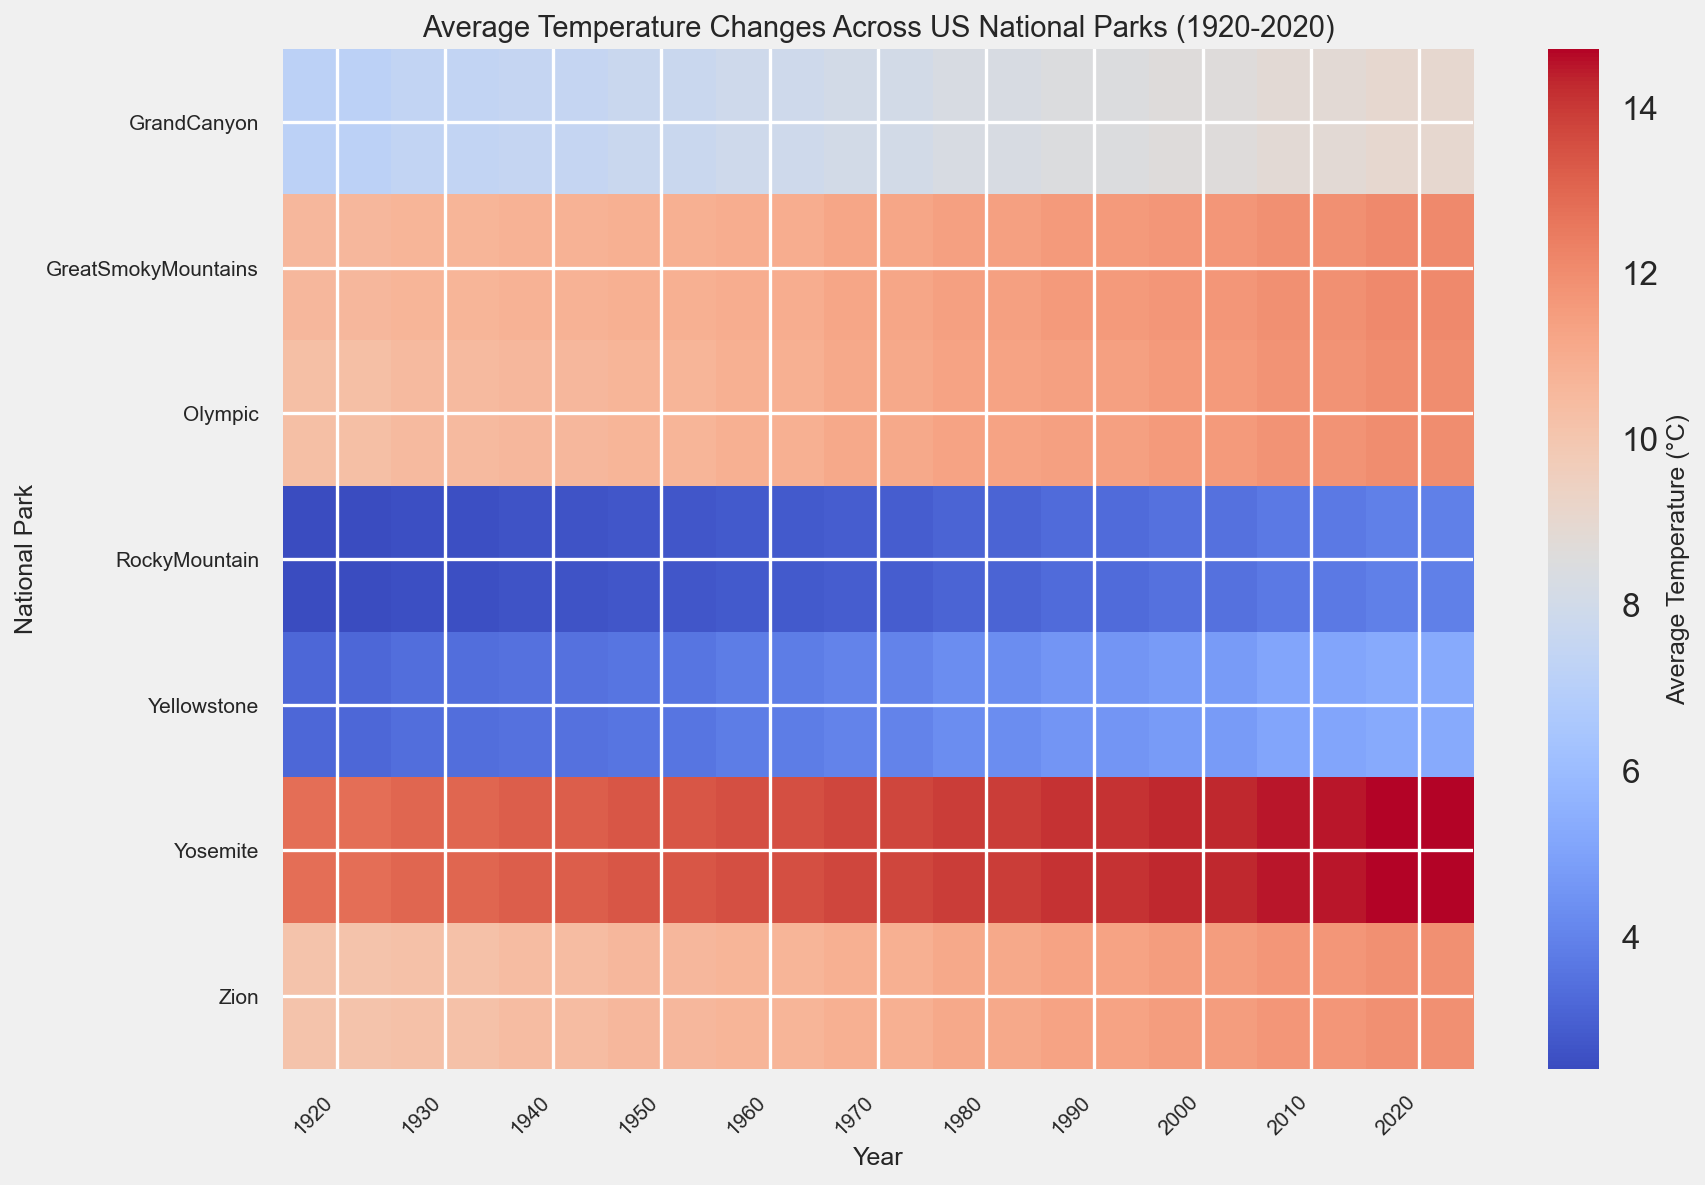What's the overall trend in average temperature for Yellowstone over the last century? By observing the color gradient from 1920 to 2020 for Yellowstone, we can see that the colors shift from cooler (bluer) to warmer (redder) over time. This indicates an increasing trend in average temperature.
Answer: Increase Which park has experienced the highest increase in average temperature from 1920 to 2020? To determine this, compare the gradient change in colors over time for each park. RockyMountain shows the smallest color change from a cooler to warmer shade, meaning it has the least increase, whereas Yellowstone shows a significant change from blue to red, indicating the highest increase.
Answer: Yellowstone In which decade did Great Smoky Mountains see the most significant temperature rise? Look at the color transition in the Great Smoky Mountains row; the most noticeable change occurs between 1980 and 1990, shifting from a cooler to a warmer color.
Answer: 1980-1990 By how many degrees has the average temperature in Zion changed from 1920 to 2020? Reference the pivot data or color transitions; in 1920, the temperature was 10.1°C and in 2020 it is 11.9°C. The difference is 11.9 - 10.1 = 1.8°C.
Answer: 1.8°C Compare the average temperature change between Olympic and Yosemite from 1920 to 2020. Which one had a larger change? For Olympic, the change is from 10.3°C to 12.0°C, which is 1.7°C. For Yosemite, the change is from 12.8°C to 14.7°C, which is 1.9°C. Yosemite has a larger change.
Answer: Yosemite Which park had the coolest average temperature in 1920? Look at the colors in the 1920 column; RockyMountain is the coolest as indicated by the darkest blue shade.
Answer: RockyMountain What was the approximate average temperature in Grand Canyon in 1960? Locate the 1960 column and Grand Canyon row; the color represents an average temperature around 7.9°C.
Answer: 7.9°C Identify the decade during which the average temperature in Yosemite first exceeded 14°C. Track the color change in the Yosemite row; noticing that it reaches a warmer shade around 14°C between 1980 and 1990.
Answer: 1980-1990 How many parks had an average temperature above 12°C in 2020? Check colors in the 2020 column; Yosemite, GreatSmokyMountains, and Olympic are above 12°C.
Answer: 3 What is the average temperature difference between Yellowstone and Grand Canyon in 2020? Reference 2020 data; Yellowstone is 5.3°C and Grand Canyon is 9.0°C. The difference is 9.0 - 5.3 = 3.7°C.
Answer: 3.7°C 